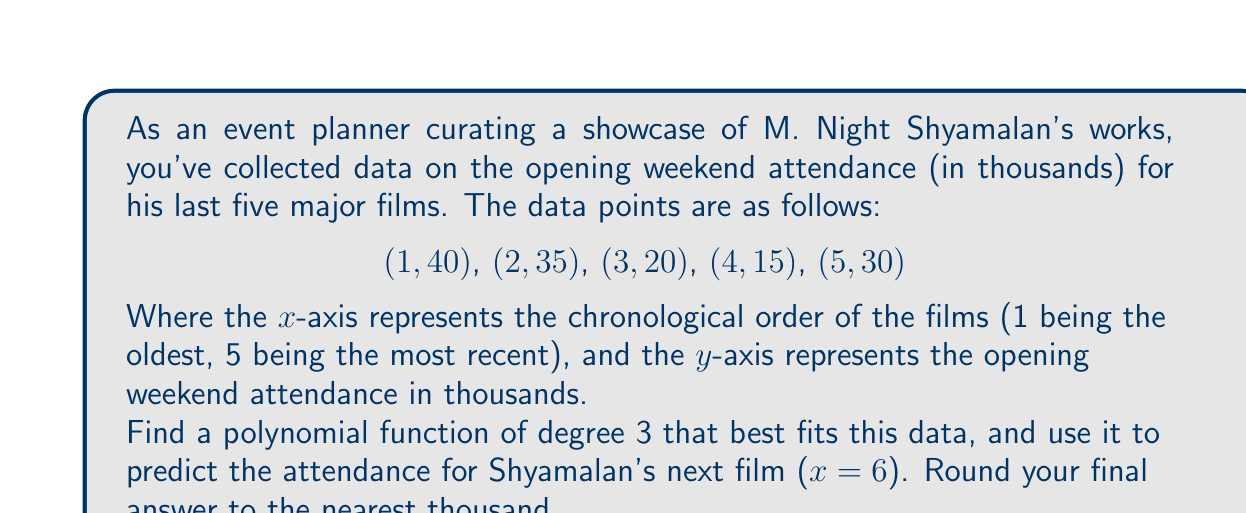Solve this math problem. To find the best-fitting polynomial of degree 3, we'll use the method of least squares regression. The general form of a cubic polynomial is:

$$ f(x) = ax^3 + bx^2 + cx + d $$

1. Set up the system of normal equations:
   $$ \sum y = an\sum x^3 + b\sum x^2 + c\sum x + dn $$
   $$ \sum xy = a\sum x^4 + b\sum x^3 + c\sum x^2 + d\sum x $$
   $$ \sum x^2y = a\sum x^5 + b\sum x^4 + c\sum x^3 + d\sum x^2 $$
   $$ \sum x^3y = a\sum x^6 + b\sum x^5 + c\sum x^4 + d\sum x^3 $$

2. Calculate the required sums:
   $\sum x = 15$, $\sum x^2 = 55$, $\sum x^3 = 225$, $\sum x^4 = 979$
   $\sum x^5 = 4425$, $\sum x^6 = 20615$
   $\sum y = 140$, $\sum xy = 460$, $\sum x^2y = 1650$, $\sum x^3y = 6200$

3. Substitute these values into the normal equations:
   $$ 140 = 225a + 55b + 15c + 5d $$
   $$ 460 = 979a + 225b + 55c + 15d $$
   $$ 1650 = 4425a + 979b + 225c + 55d $$
   $$ 6200 = 20615a + 4425b + 979c + 225d $$

4. Solve this system of equations using matrix methods or a calculator. The solution is:
   $$ a = 2.5, b = -22.5, c = 57, d = 3 $$

5. Therefore, the best-fitting cubic polynomial is:
   $$ f(x) = 2.5x^3 - 22.5x^2 + 57x + 3 $$

6. To predict the attendance for the next film (x = 6), substitute x = 6 into the equation:
   $$ f(6) = 2.5(6^3) - 22.5(6^2) + 57(6) + 3 $$
   $$ = 540 - 810 + 342 + 3 = 75 $$

7. Rounding to the nearest thousand:
   75,000 attendees
Answer: 75,000 attendees 